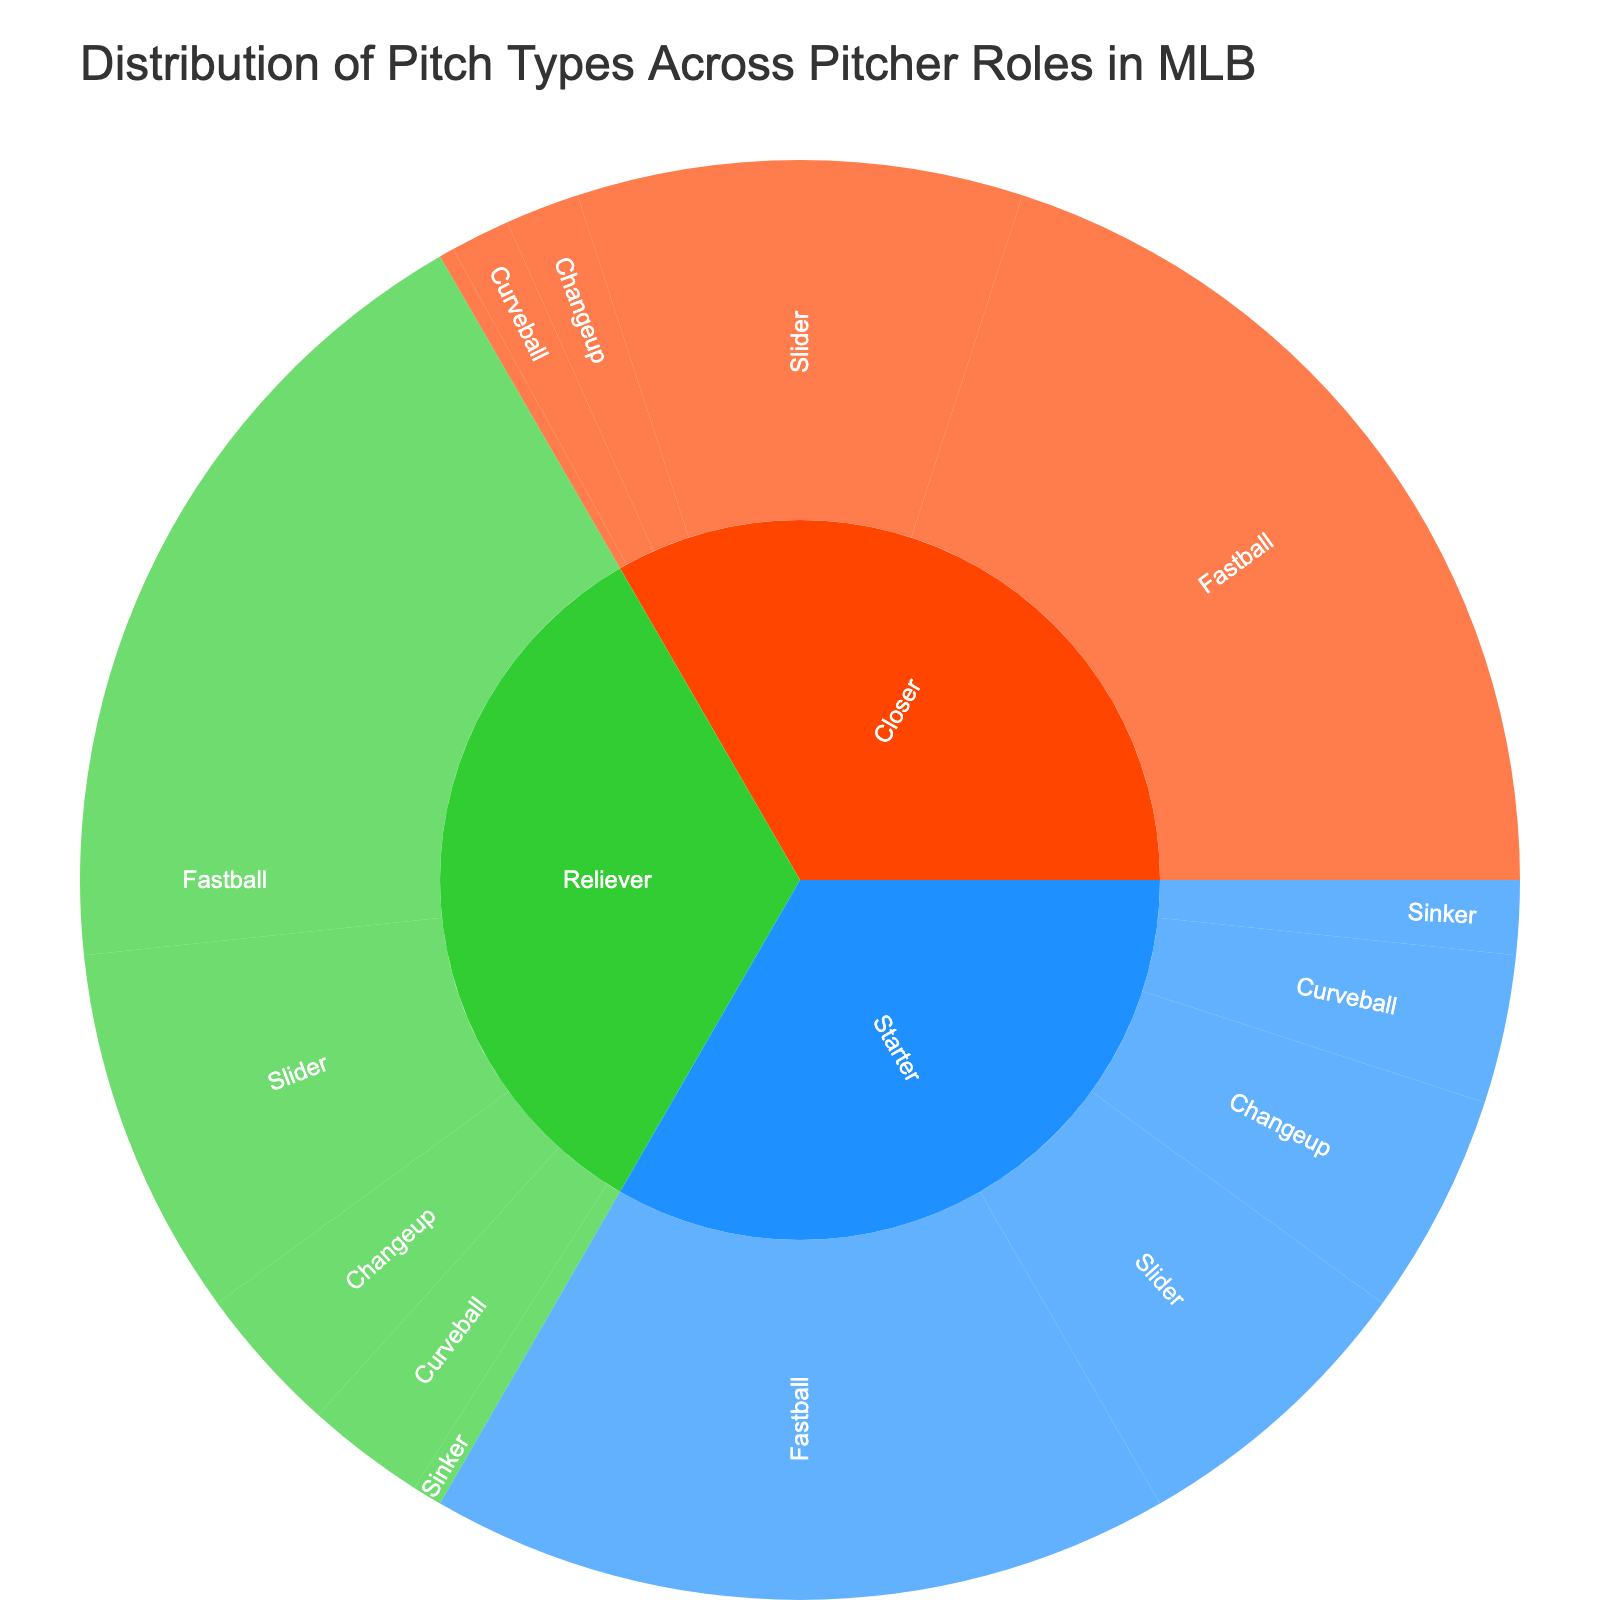What is the title of the figure? The title is usually located at the top of the figure, providing a concise description of what the chart represents. In this plot, the title is "Distribution of Pitch Types Across Pitcher Roles in MLB."
Answer: Distribution of Pitch Types Across Pitcher Roles in MLB What percentage of pitches thrown by starters are fastballs? Look at the 'Starter' section of the sunburst plot and identify the segment labeled 'Fastball.' The hover data or label indicates the percentage of pitches.
Answer: 50% Which role uses the slider the most, and what is the percentage? Compare the segments for 'Slider' under different roles: Starter, Reliever, and Closer. The role with the largest segment for 'Slider' has the highest percentage use.
Answer: Closer, 30% What is the total percentage of pitches thrown by relievers that are either changeups or curveballs? Locate the 'Reliever' section and sum the percentages of 'Changeup' and 'Curveball' segments. The hover data or labels will provide the percentage values.
Answer: Changeup (10%) + Curveball (8%) = 18% Which pitch type has the smallest percentage for closers? Examine the sections under 'Closer' and identify the segment with the smallest percentage value.
Answer: Sinker, 1% Is the percentage of fastballs greater for relievers or starters, and by how much? Identify the percentages of fastballs for 'Reliever' and 'Starter' from their respective segments. Subtract the smaller percentage from the larger one to find the difference.
Answer: Relievers by 5% (55% - 50%) What are the relative proportions of curveballs thrown by different pitcher roles? Look at the curveball segments under Starter, Reliever, and Closer. Compare their sizes to understand the proportion of curveballs used by each role. The exact percentages can be found in the hover data or labels.
Answer: Starters: 10%, Relievers: 8%, Closers: 4% Which pitcher role has the highest dependency on a single pitch type? Examine each role (Starter, Reliever, and Closer) and identify the largest segment within each. The segment with the highest percentage indicates the highest dependency on that pitch type.
Answer: Closer (Fastball, 60%) Between which two roles is the difference in usage of the changeup pitch the smallest? Compare the percentages of changeup usage across all roles: Starter, Reliever, Closer. Calculate the absolute difference between their percentages and find the smallest difference.
Answer: Starters and Relievers (15% - 10% = 5%) What combined percentage of pitches thrown by closers are either fastballs or sliders? Add the percentages of 'Fastball' and 'Slider' segments under the 'Closer' section. The values can be found in the hover data or labels.
Answer: Fastball (60%) + Slider (30%) = 90% 